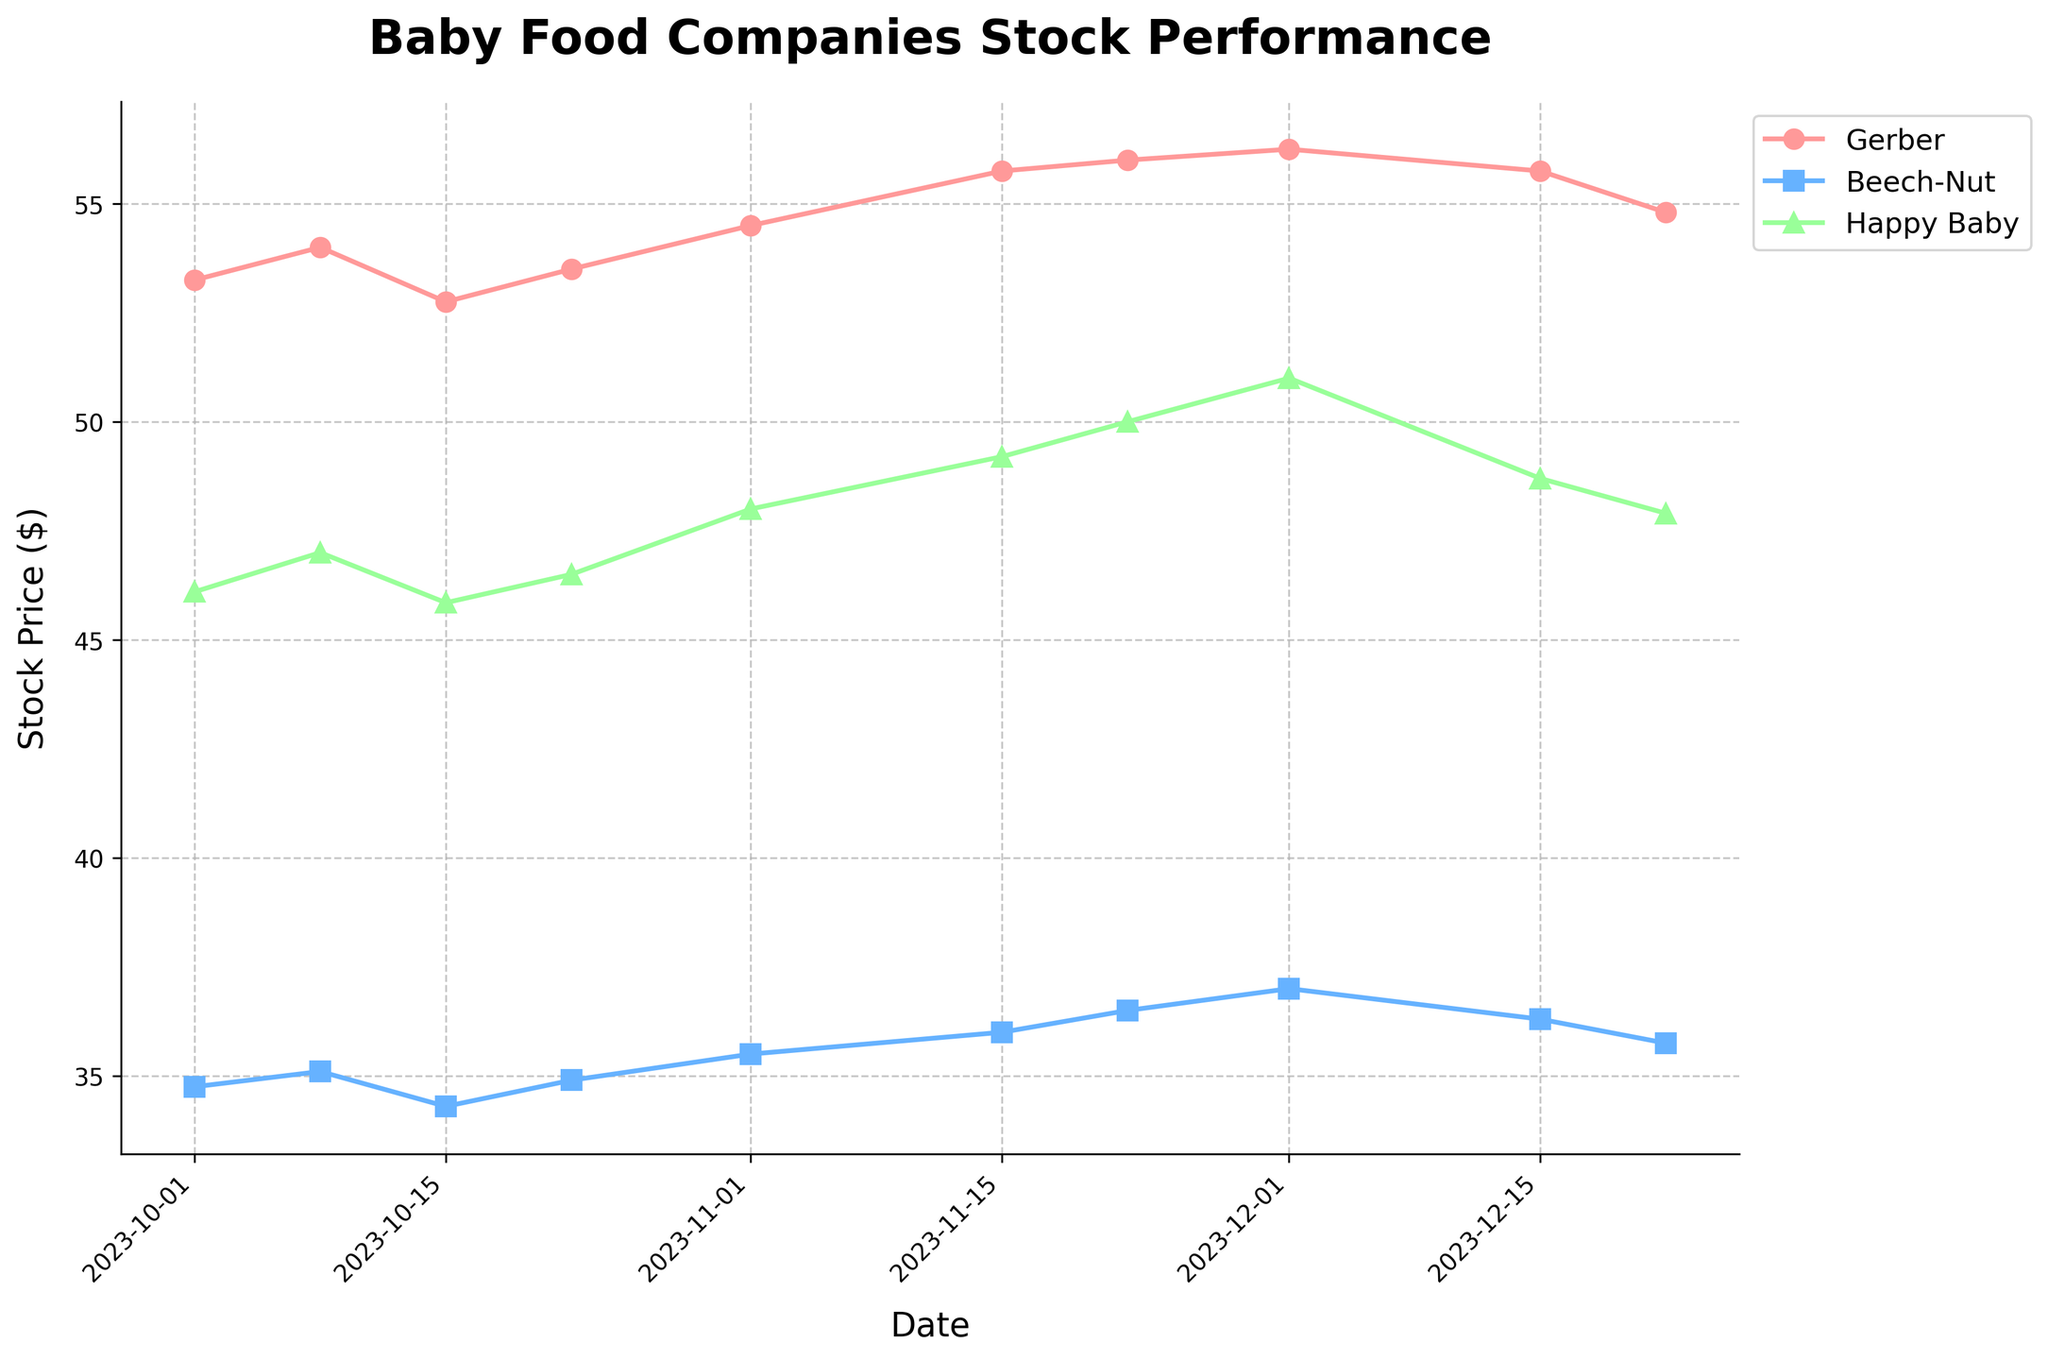What are the three companies shown in the plot? The plot features three companies, and you can identify them by looking at the labels in the legend. The legend is on the upper left side of the plot, outside the main graph area.
Answer: Gerber, Beech-Nut, Happy Baby Which company had the highest stock price on December 1, 2023? To find this, you need to look at the plotted data points for December 1 (the x-axis labeled "Date") and check which company’s stock price is the highest. Each line represents a company with distinct markers and colors.
Answer: Happy Baby By how much did Gerber's stock price change from November 1, 2023, to November 22, 2023? Look at the stock price data points for Gerber on November 1 and November 22. Check the y-axis labels corresponding to these dates to calculate the difference. On November 1, it was $54.50 and on November 22, it was $56.00. So, the change is $56.00 - $54.50.
Answer: $1.50 Which company experienced the most significant increase in stock price from October 15, 2023, to December 1, 2023? To figure this out, you would track each company's stock price on October 15 and December 1 and calculate the difference. You need to find the individual differences and compare them:
- Gerber: $56.25 - $52.75 = $3.50
- Beech-Nut: $37.00 - $34.30 = $2.70
- Happy Baby: $51.00 - $45.85 = $5.15
Answer: Happy Baby Which company has the most noticeable price dip in December 2023? Examine the plot lines for each company during the dates in December. Check the dips for each line and see which one is the most significant. The x-axis representing time should help identify this. Gerber's stock price decreases from $56.25 on December 1 to $54.80 on December 22.
Answer: Gerber 